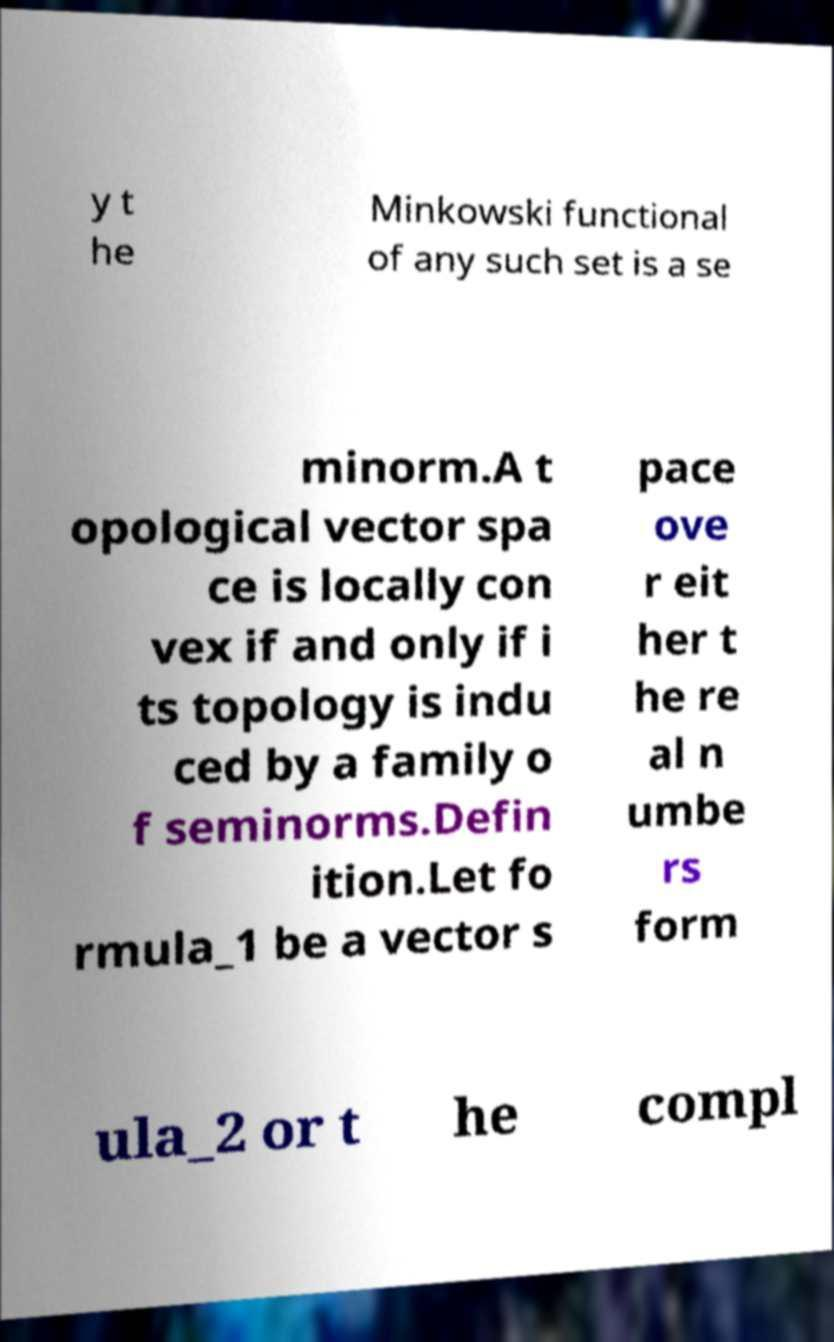There's text embedded in this image that I need extracted. Can you transcribe it verbatim? y t he Minkowski functional of any such set is a se minorm.A t opological vector spa ce is locally con vex if and only if i ts topology is indu ced by a family o f seminorms.Defin ition.Let fo rmula_1 be a vector s pace ove r eit her t he re al n umbe rs form ula_2 or t he compl 